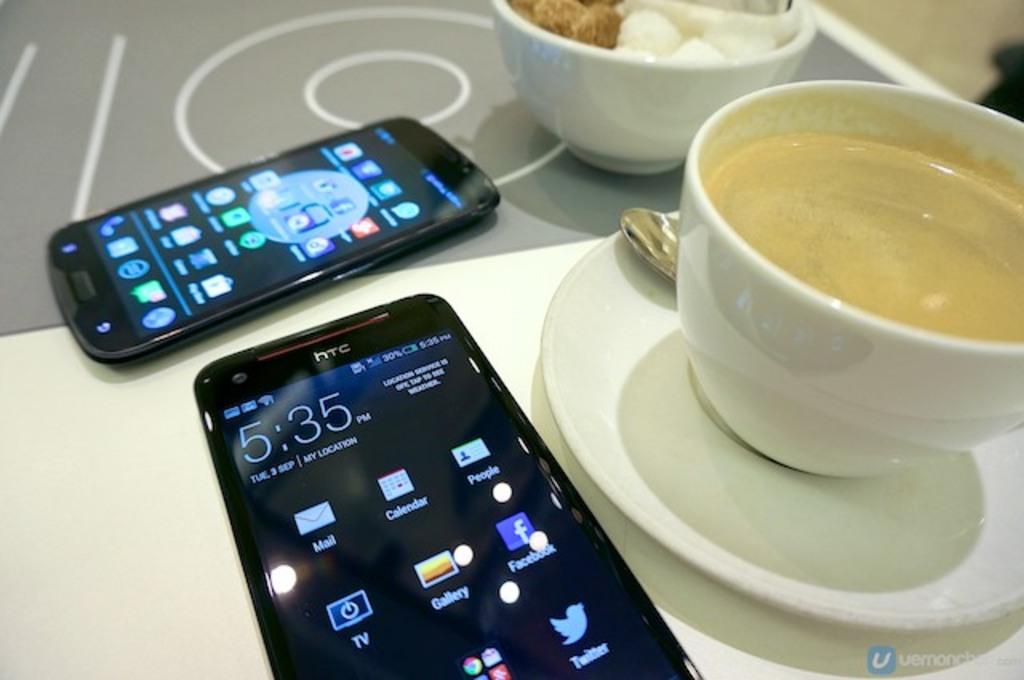What time does the phone say it is?
Keep it short and to the point. 5:35. Whats the name of the first app to the top left on the screen?
Keep it short and to the point. Mail. 